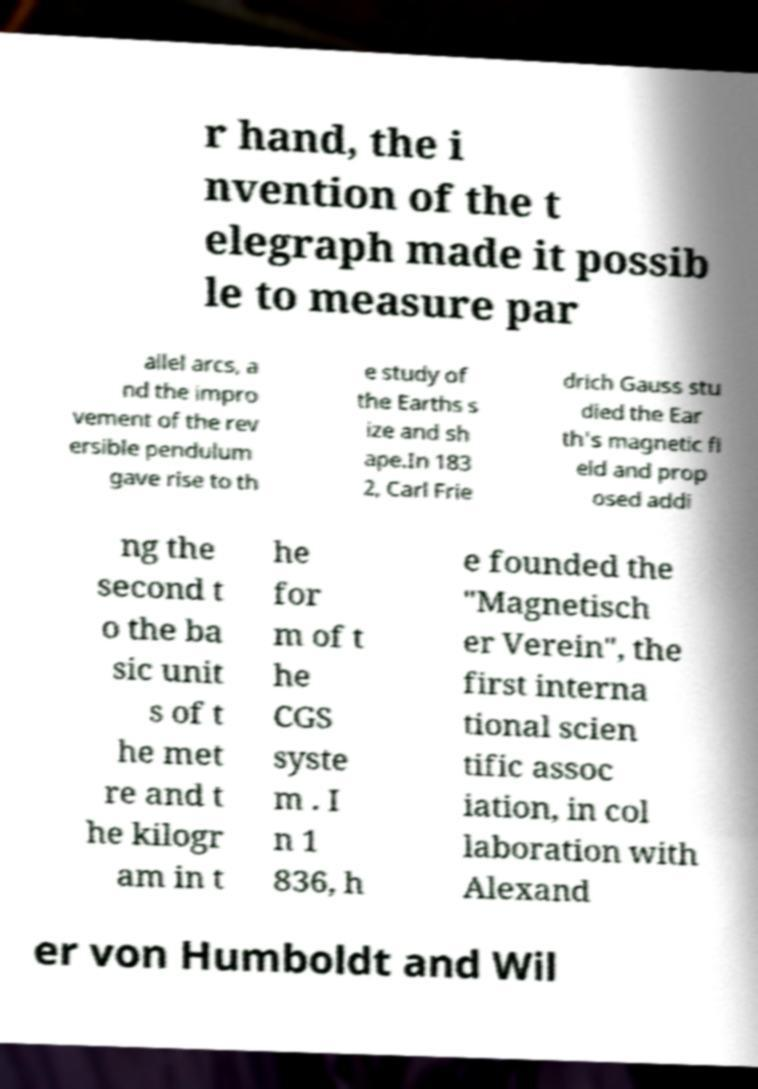Could you assist in decoding the text presented in this image and type it out clearly? r hand, the i nvention of the t elegraph made it possib le to measure par allel arcs, a nd the impro vement of the rev ersible pendulum gave rise to th e study of the Earths s ize and sh ape.In 183 2, Carl Frie drich Gauss stu died the Ear th's magnetic fi eld and prop osed addi ng the second t o the ba sic unit s of t he met re and t he kilogr am in t he for m of t he CGS syste m . I n 1 836, h e founded the "Magnetisch er Verein", the first interna tional scien tific assoc iation, in col laboration with Alexand er von Humboldt and Wil 